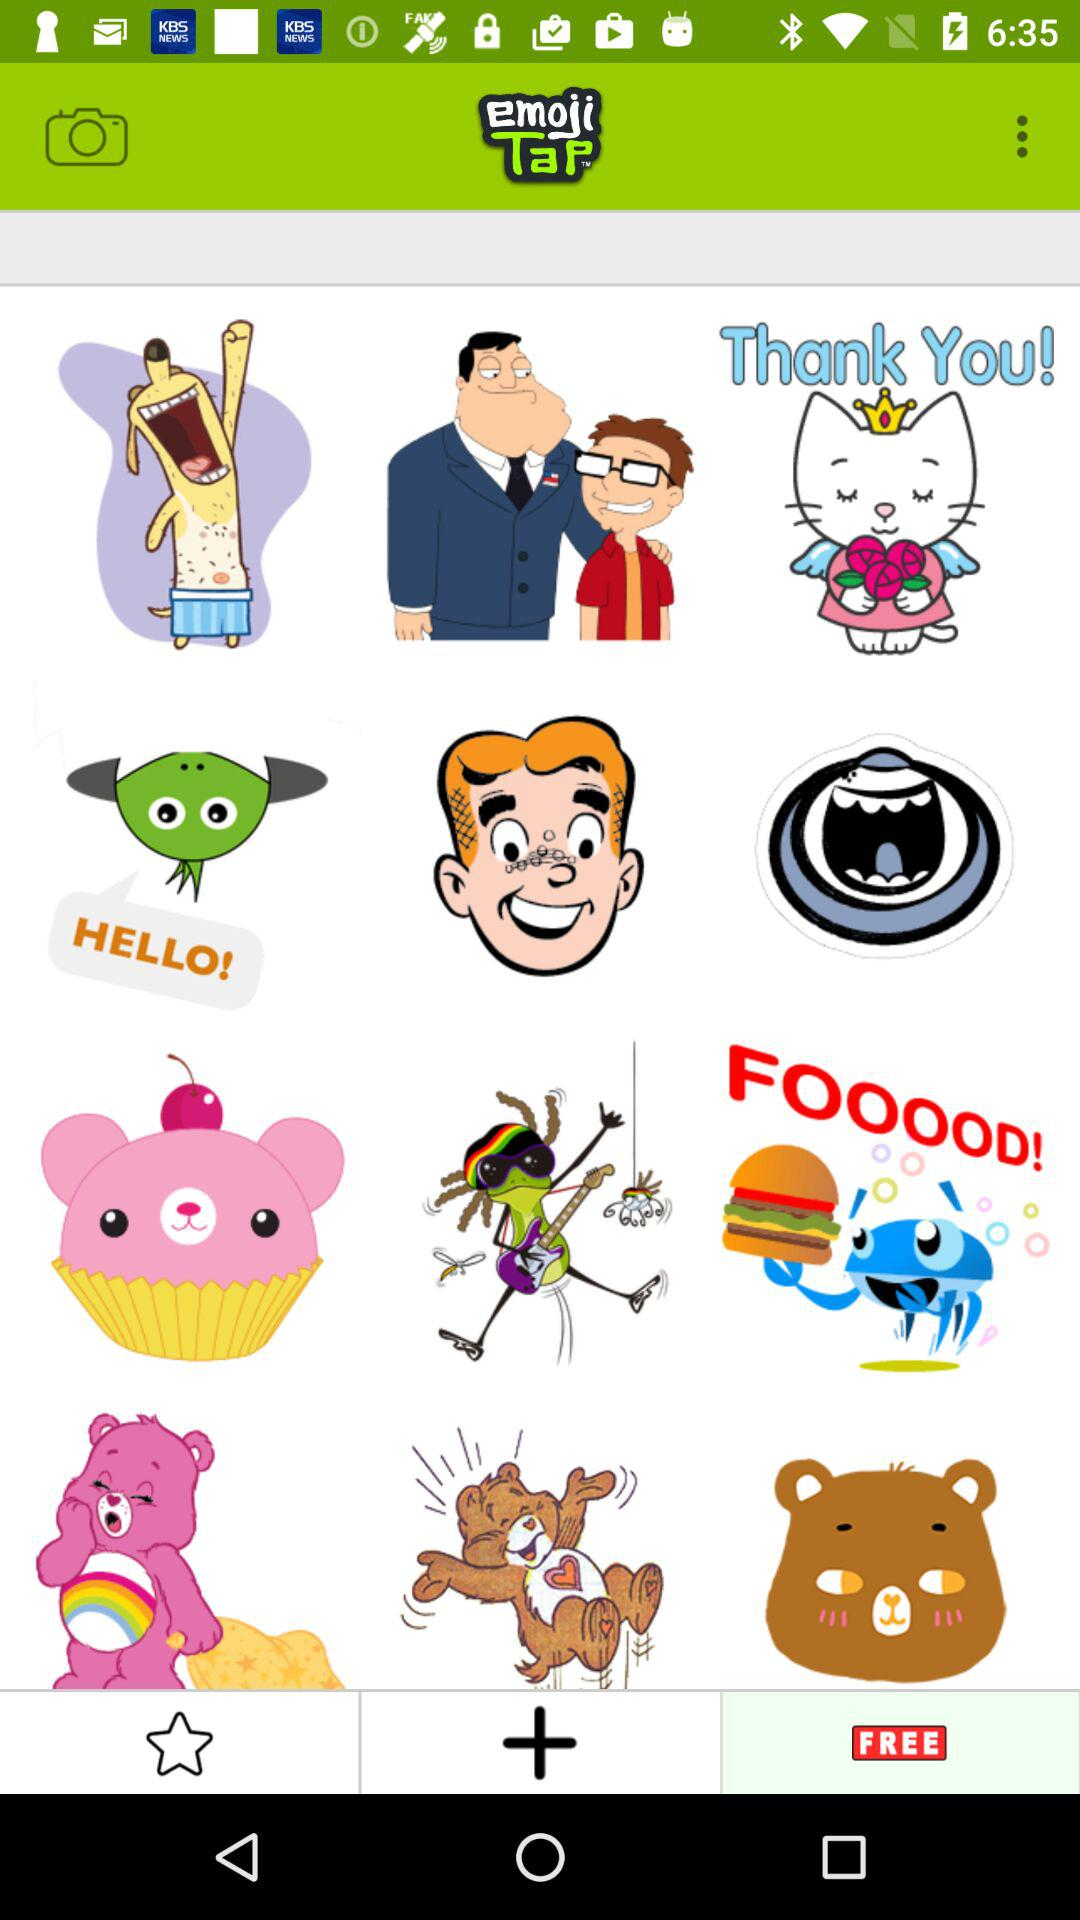What is the name of the application? The name of the application is "emoji TaP™". 